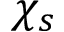<formula> <loc_0><loc_0><loc_500><loc_500>\chi _ { s }</formula> 